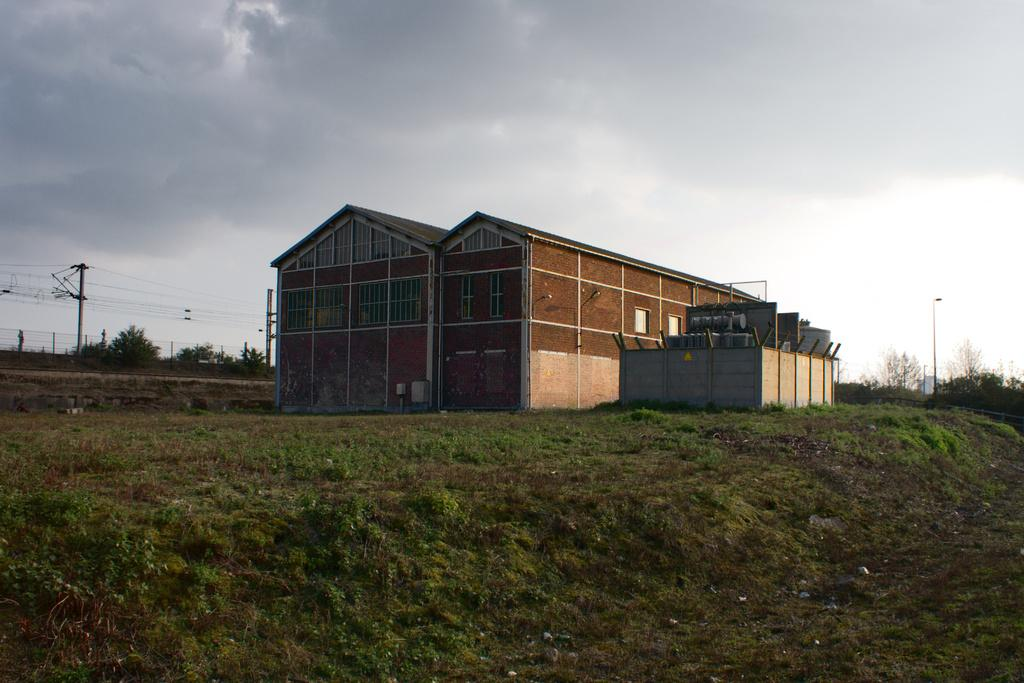What type of structures can be seen in the image? There are sheds in the image. What type of electrical equipment is present in the image? Transformers are present in the image. What type of infrastructure is visible in the image? Electric poles and electric cables are present in the image. What type of boundary is in the image? Fences are in the image. What type of street furniture is visible in the image? There is a street pole and a street light visible in the image. What type of natural elements are present in the image? Trees are present in the image. What is visible in the background of the image? The sky is visible in the image, and clouds are present in the sky. What type of oatmeal is being served at the street light in the image? There is no oatmeal present in the image, and it is not being served at the street light. What order is being followed by the transformers in the image? The transformers do not follow any specific order in the image; they are simply present. 